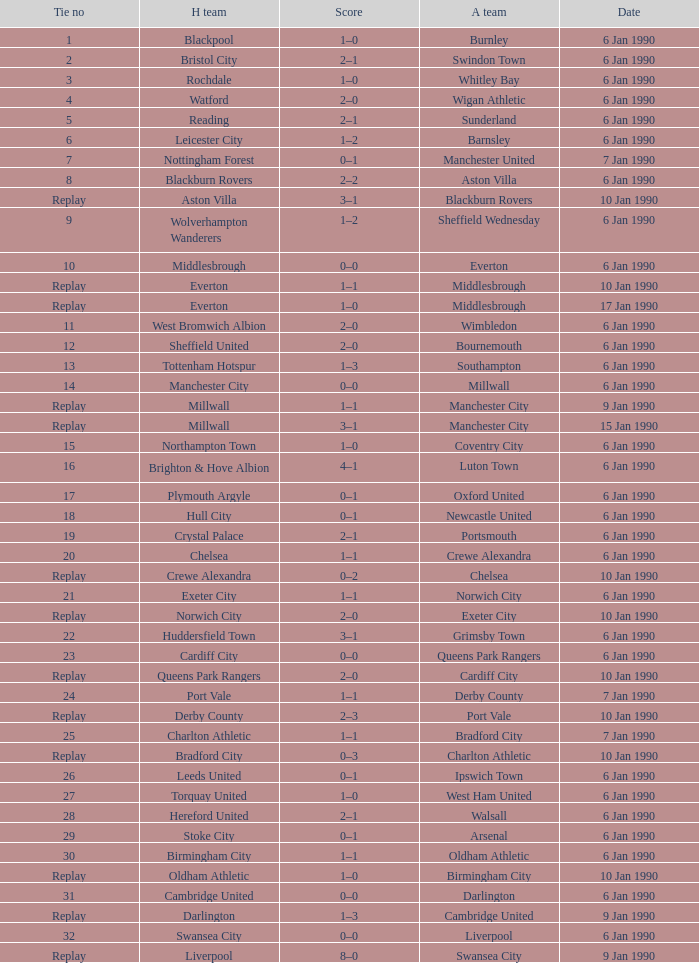What date did home team liverpool play? 9 Jan 1990. 